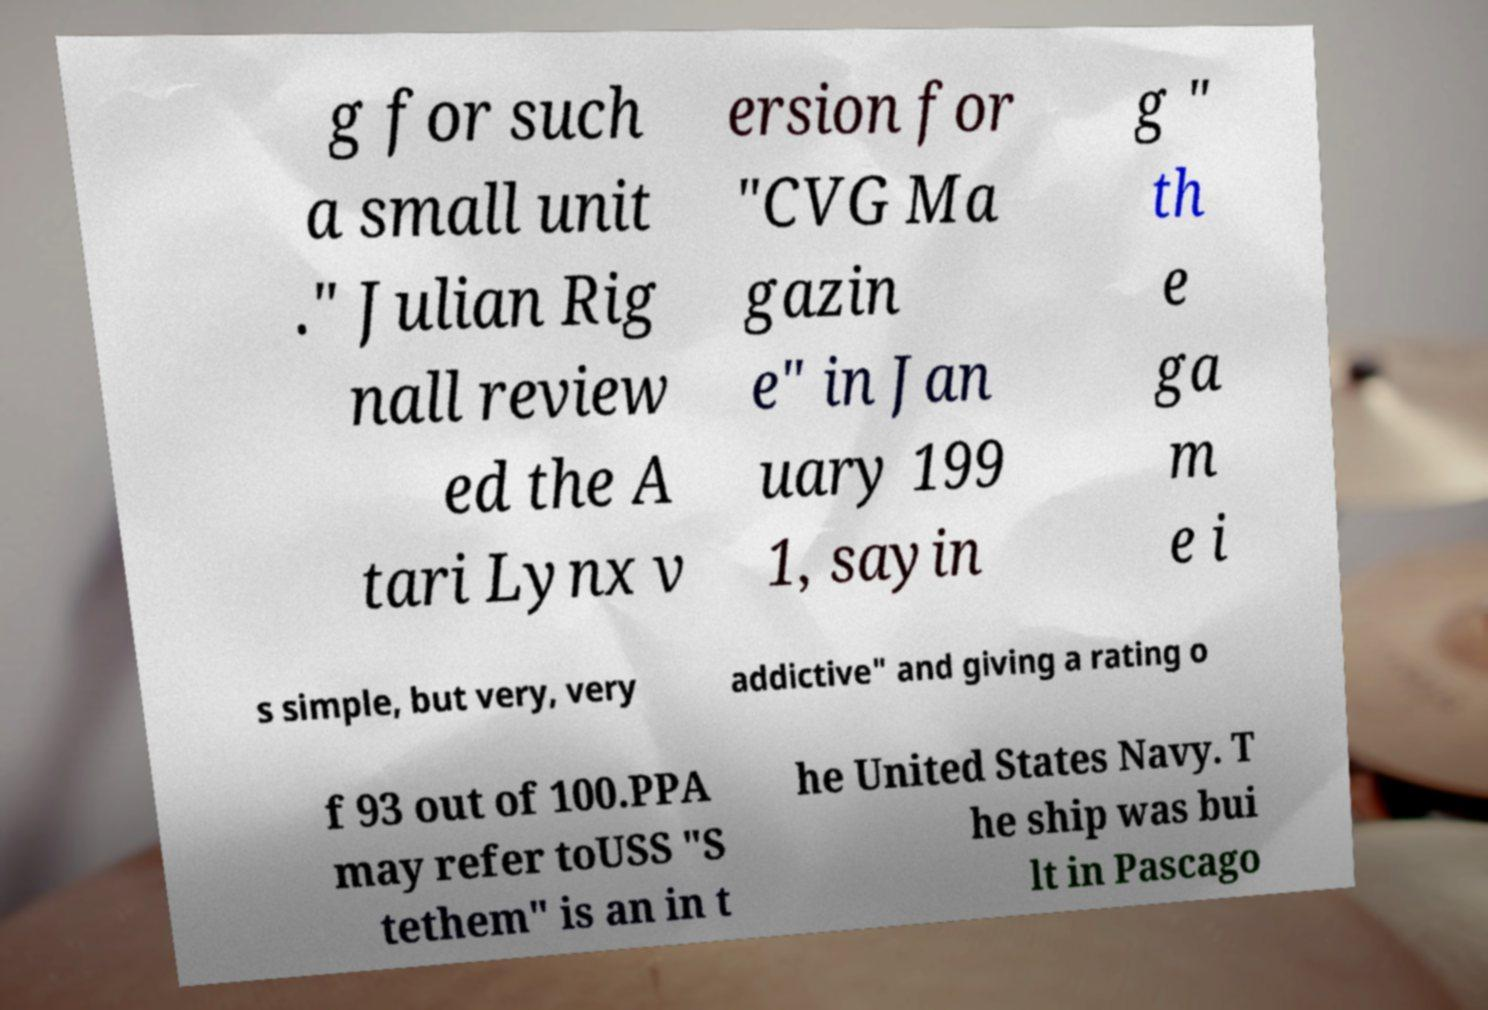I need the written content from this picture converted into text. Can you do that? g for such a small unit ." Julian Rig nall review ed the A tari Lynx v ersion for "CVG Ma gazin e" in Jan uary 199 1, sayin g " th e ga m e i s simple, but very, very addictive" and giving a rating o f 93 out of 100.PPA may refer toUSS "S tethem" is an in t he United States Navy. T he ship was bui lt in Pascago 